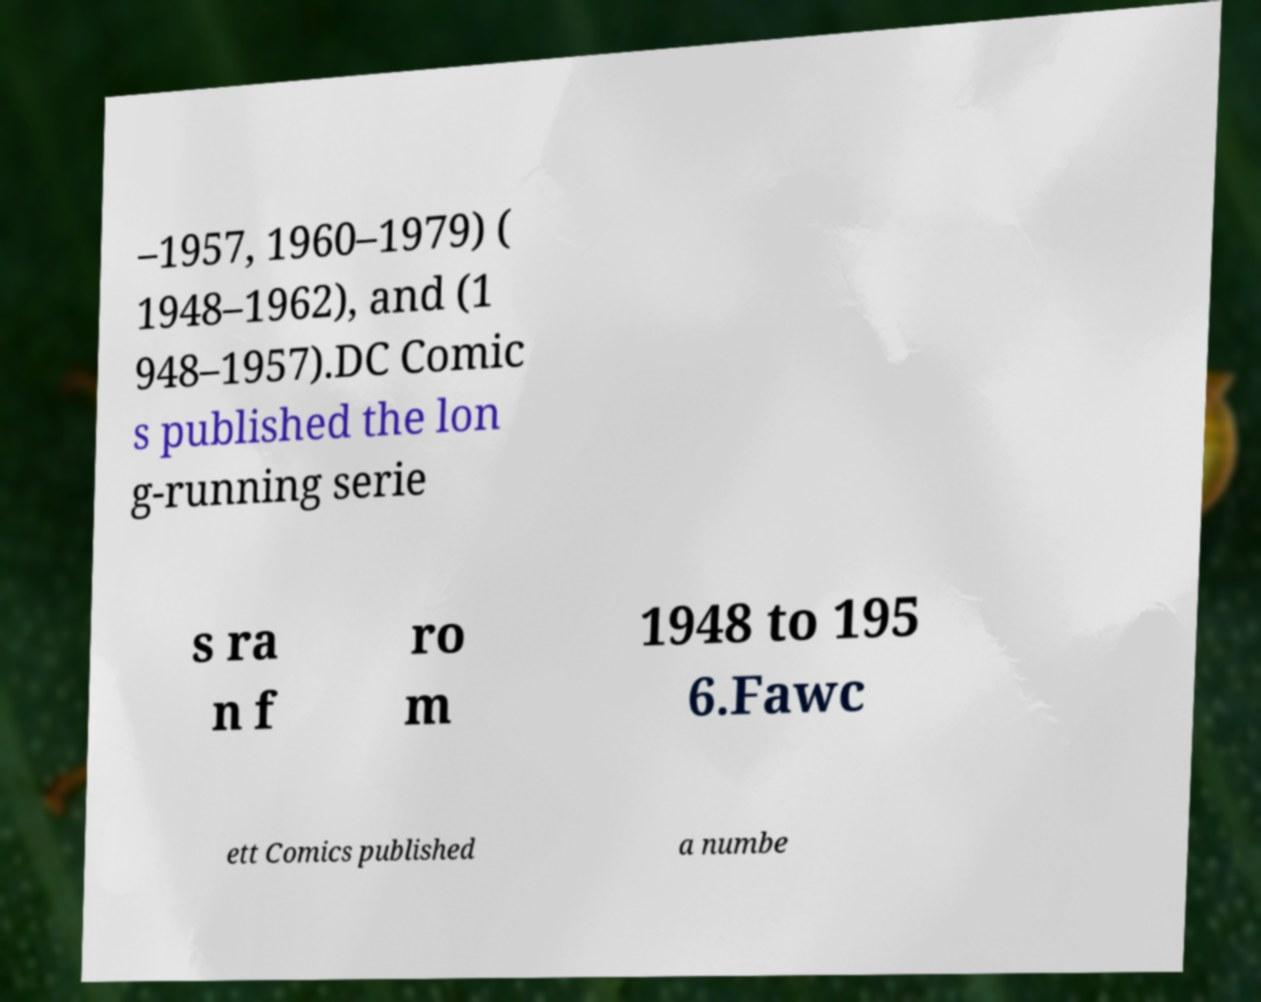Can you read and provide the text displayed in the image?This photo seems to have some interesting text. Can you extract and type it out for me? –1957, 1960–1979) ( 1948–1962), and (1 948–1957).DC Comic s published the lon g-running serie s ra n f ro m 1948 to 195 6.Fawc ett Comics published a numbe 